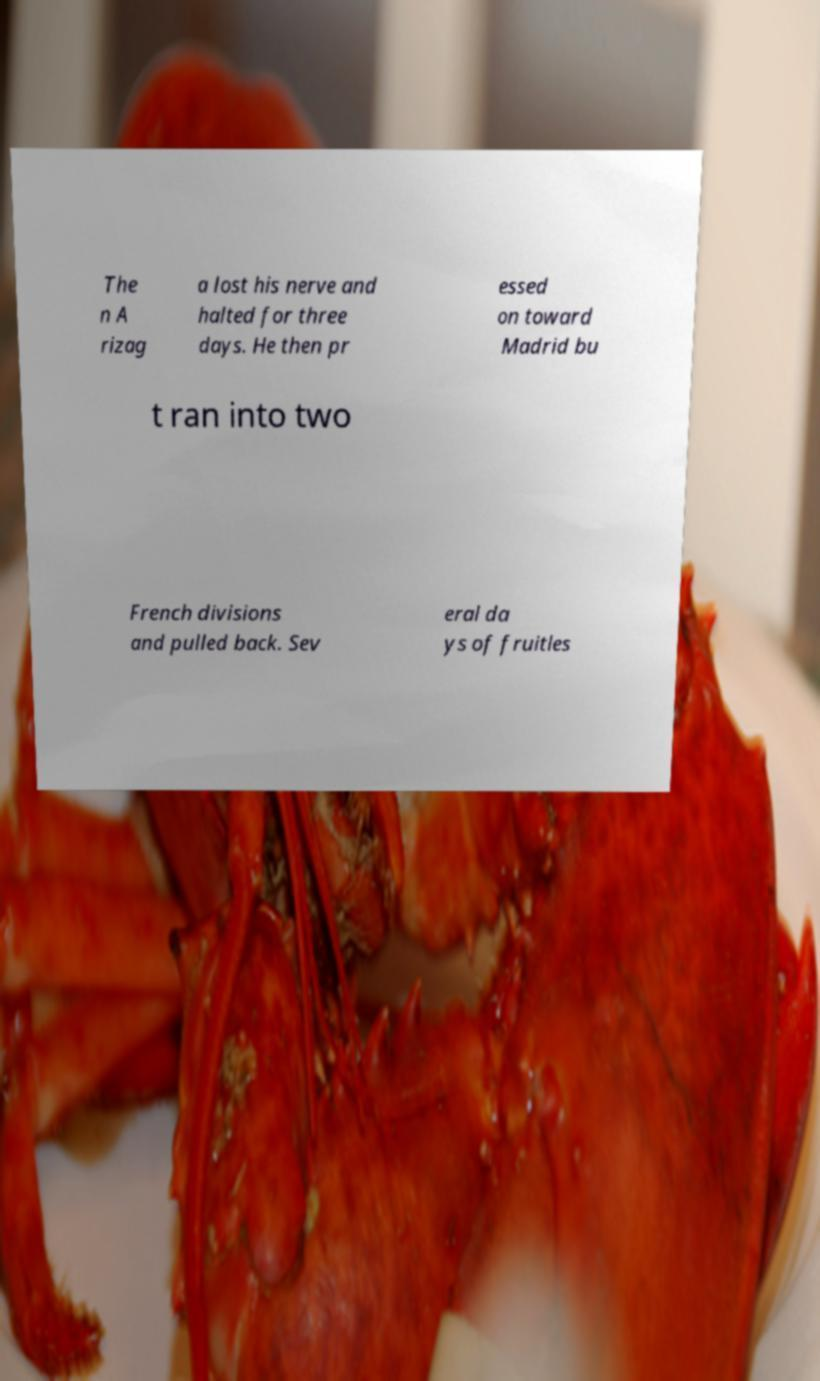For documentation purposes, I need the text within this image transcribed. Could you provide that? The n A rizag a lost his nerve and halted for three days. He then pr essed on toward Madrid bu t ran into two French divisions and pulled back. Sev eral da ys of fruitles 